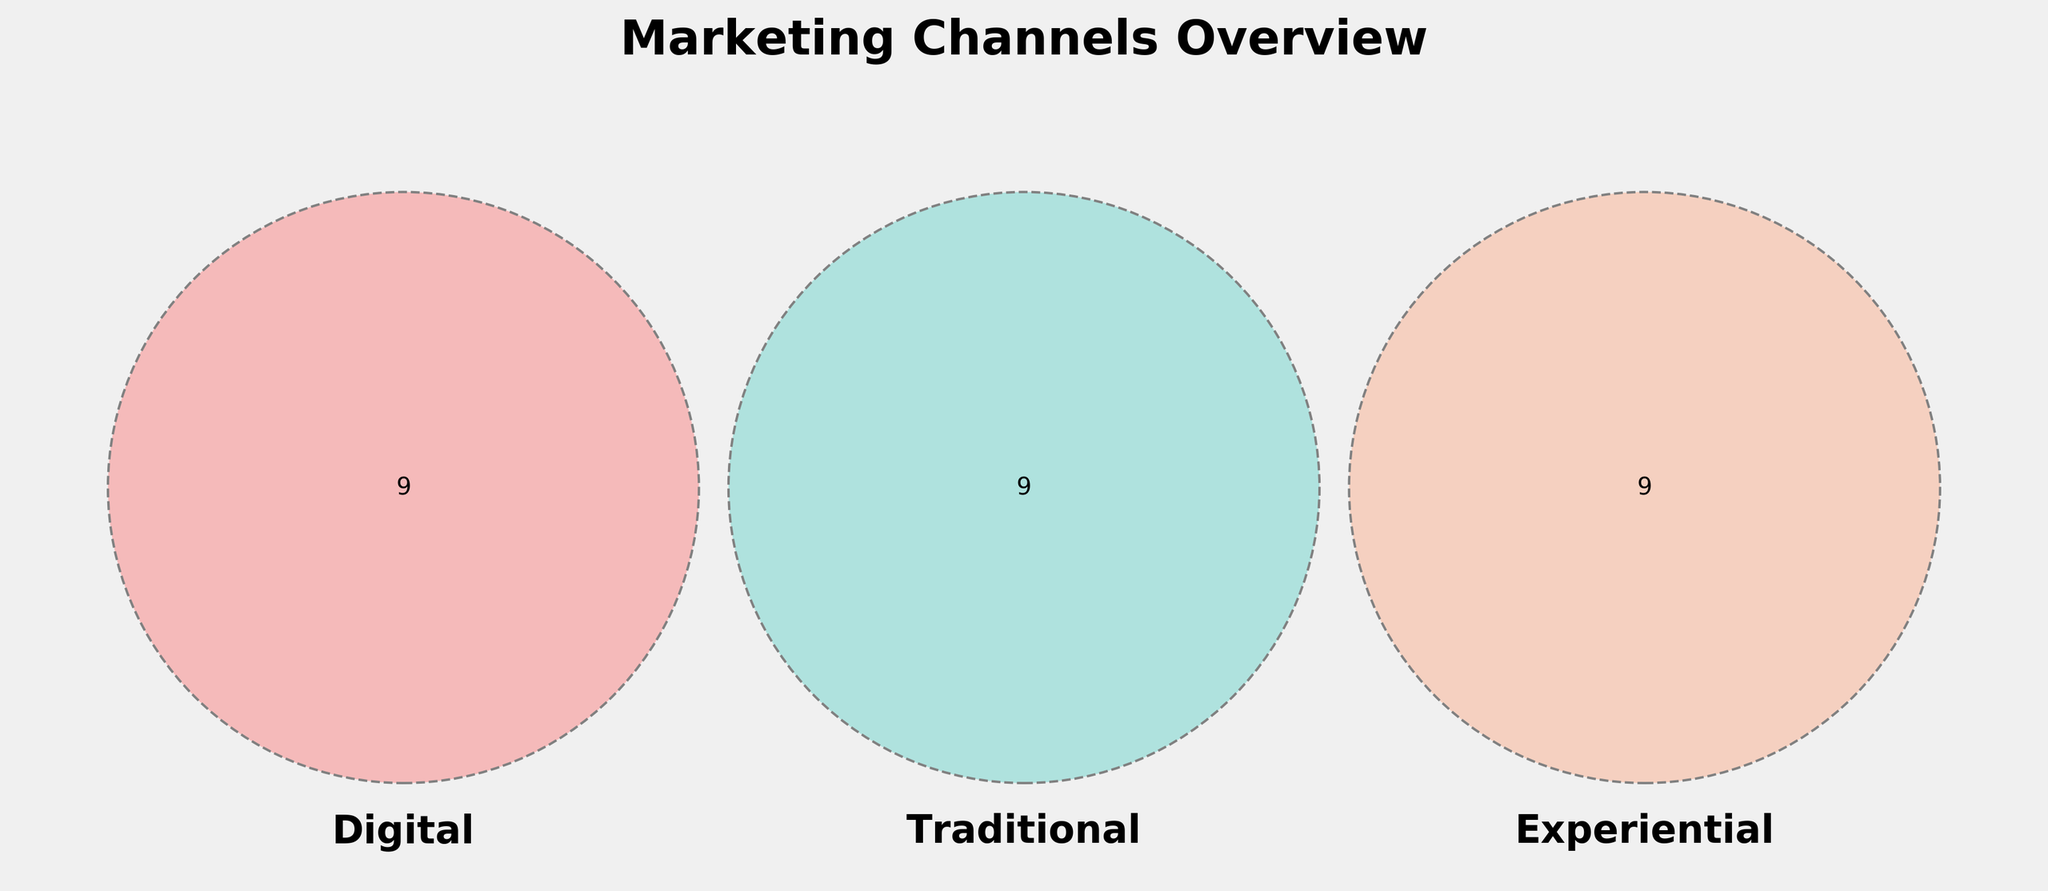What's the title of the figure? The title is located at the top of the figure. It is displayed in bold and large font.
Answer: Marketing Channels Overview What color is used to represent the “Digital” category? The "Digital" category is represented by looking at the Venn Diagram and identifying the color associated with Digital.
Answer: Red How many channels are exclusive to the “Experiential” category? Count the number of unique channels listed solely in the "Experiential" circle that do not overlap with other categories.
Answer: 9 Which category has the most exclusive channels? Compare the count of unique channels in each of the "Digital", "Traditional", and "Experiential" circles. Identify the one with the highest count.
Answer: Experiential Do any marketing channels fall into all three categories? Check the overlapping area where all three circles intersect and see if any channels are listed there.
Answer: No How many marketing channels are there in total across all categories? Sum up the unique marketing channels from all three categories considering overlaps only once.
Answer: 27 Are there any channels shared between “Digital” and “Traditional” but not “Experiential”? Look at the section where "Digital" and "Traditional" circles overlap but do not intersect with "Experiential".
Answer: No How many channels are shared between “Digital” and “Experiential”? Count the channels in the overlapping area of the "Digital" and "Experiential" circles.
Answer: 0 Which marketing channel types are represented by “TV ads” and “VR experiences”? Identify which categories the mentioned channels belong to by referring to their positions in the circles.
Answer: TV ads: Traditional, VR experiences: Experiential Does “Content marketing” belong to more than one category? Check the position of “Content marketing” within the Venn Diagram to see if it falls under multiple categories.
Answer: No 